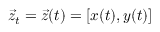<formula> <loc_0><loc_0><loc_500><loc_500>\vec { z } _ { t } = \vec { z } ( t ) = [ x ( t ) , y ( t ) ]</formula> 